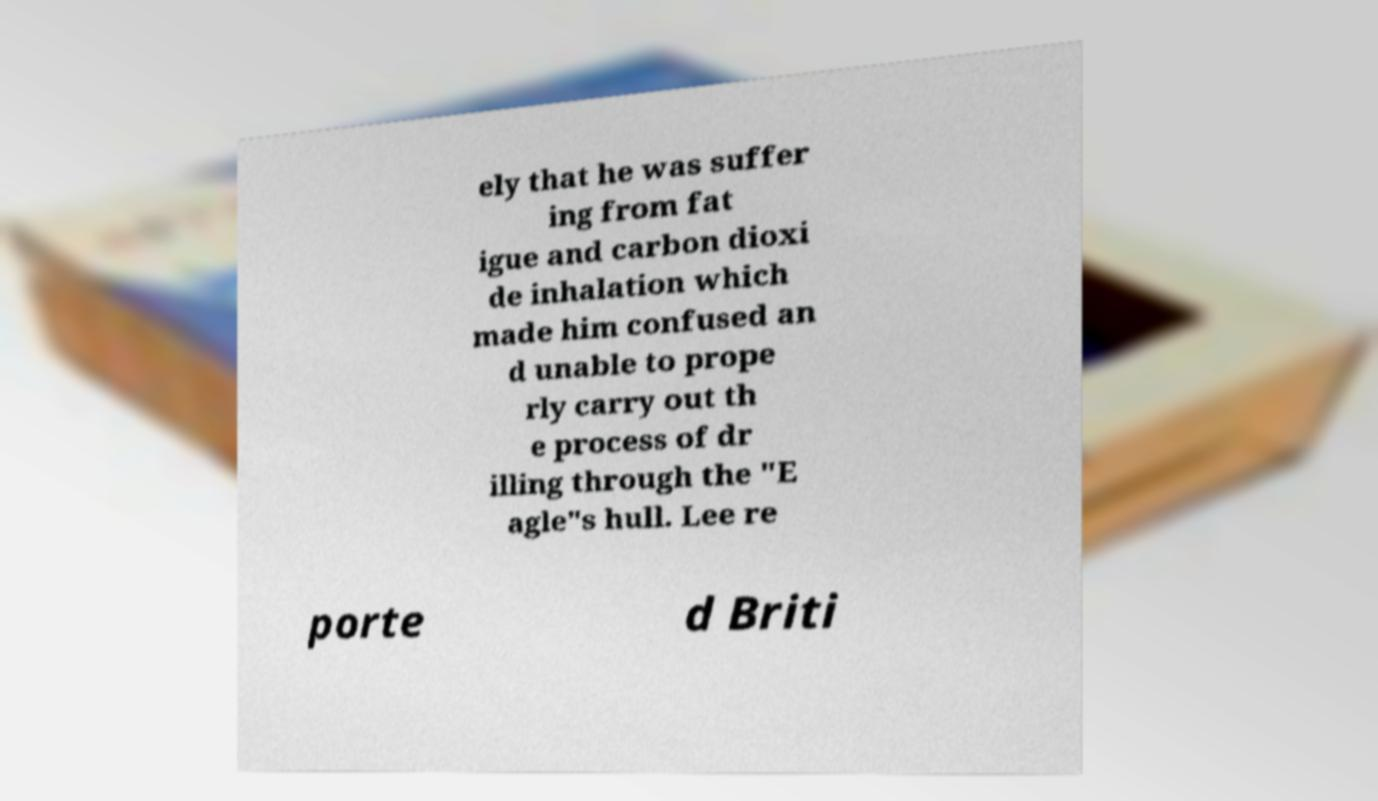Please identify and transcribe the text found in this image. ely that he was suffer ing from fat igue and carbon dioxi de inhalation which made him confused an d unable to prope rly carry out th e process of dr illing through the "E agle"s hull. Lee re porte d Briti 